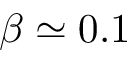Convert formula to latex. <formula><loc_0><loc_0><loc_500><loc_500>\beta \simeq 0 . 1</formula> 